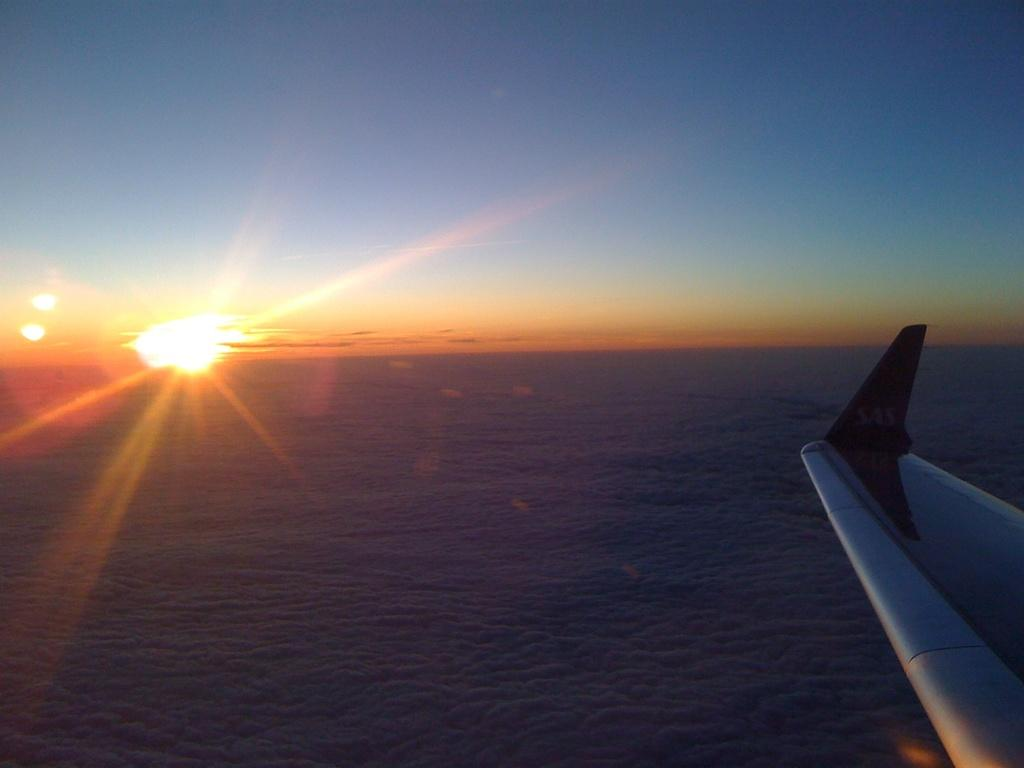What is the main subject of the image? The main subject of the image is a plane wing. What can be seen in the background of the image? There are clouds and the sun visible in the image, and the sky is also visible. What language is being spoken by the clouds in the image? There is no oven or language spoken by the clouds in the image. Clouds are a natural atmospheric phenomenon and do not speak any language. 